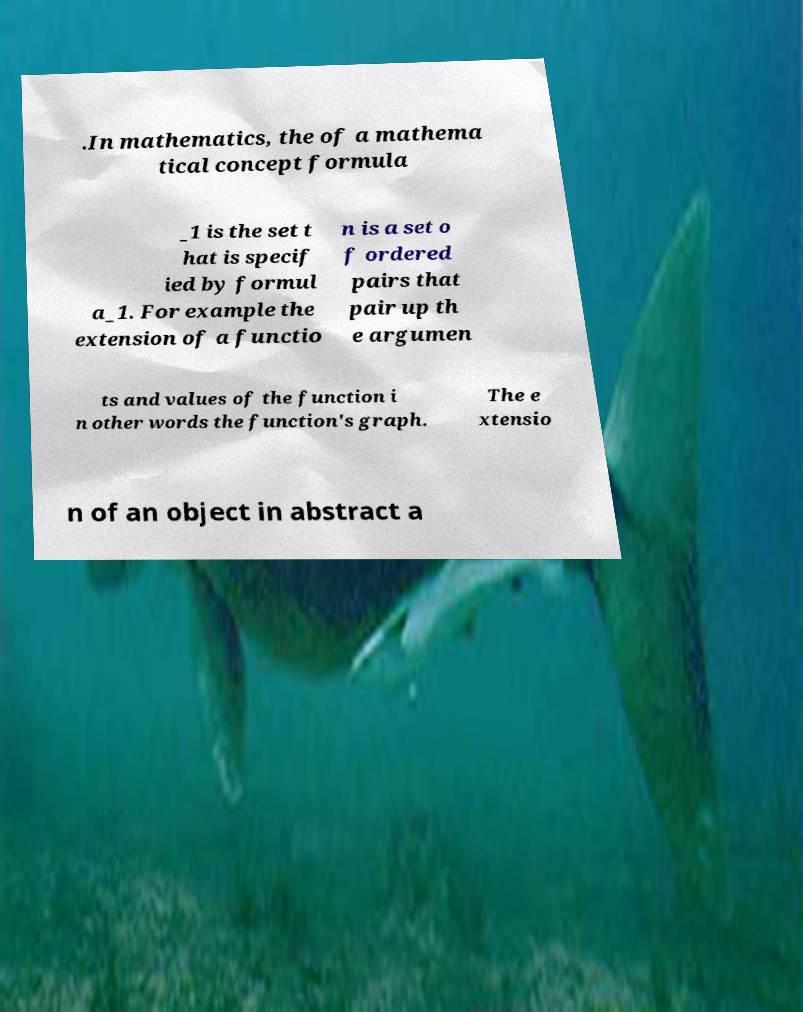Could you extract and type out the text from this image? .In mathematics, the of a mathema tical concept formula _1 is the set t hat is specif ied by formul a_1. For example the extension of a functio n is a set o f ordered pairs that pair up th e argumen ts and values of the function i n other words the function's graph. The e xtensio n of an object in abstract a 